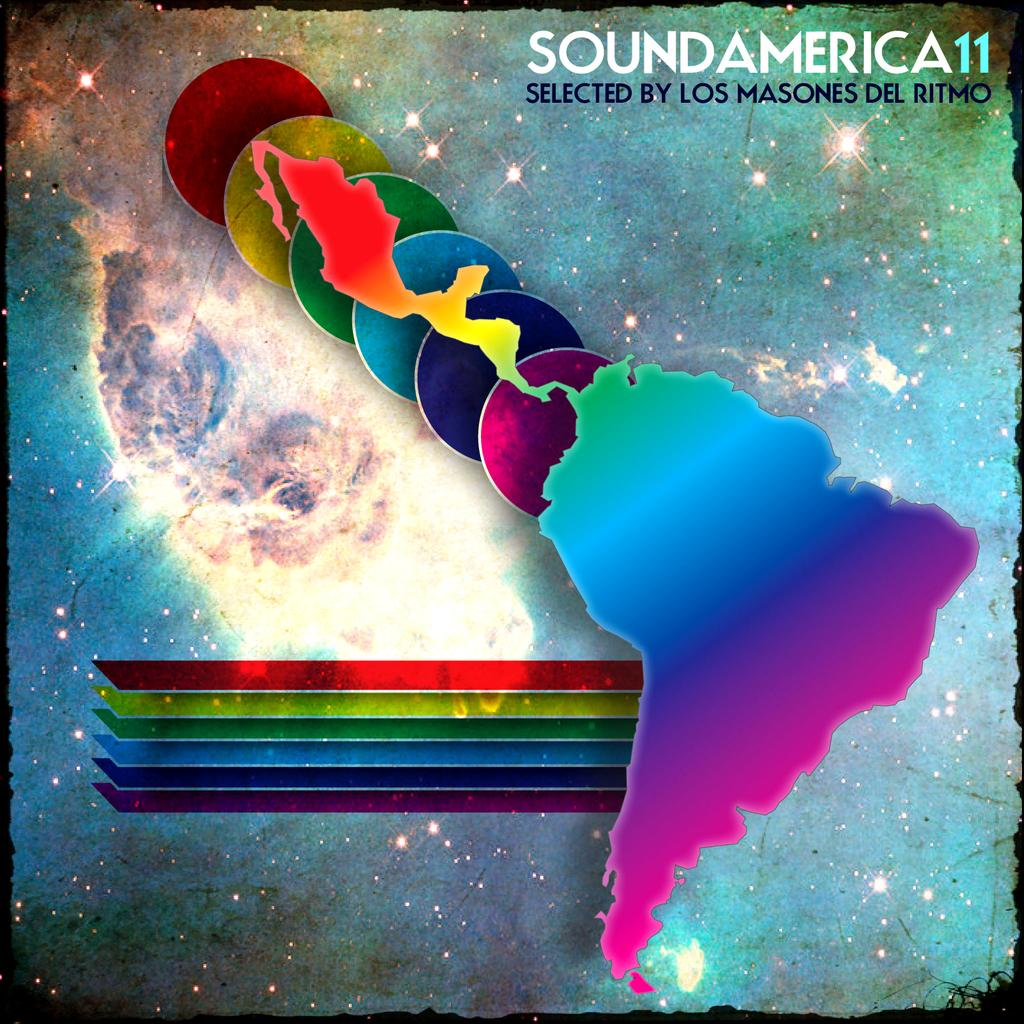<image>
Offer a succinct explanation of the picture presented. A colorful poster showing Central and South America with the words SoundAmerica11. 